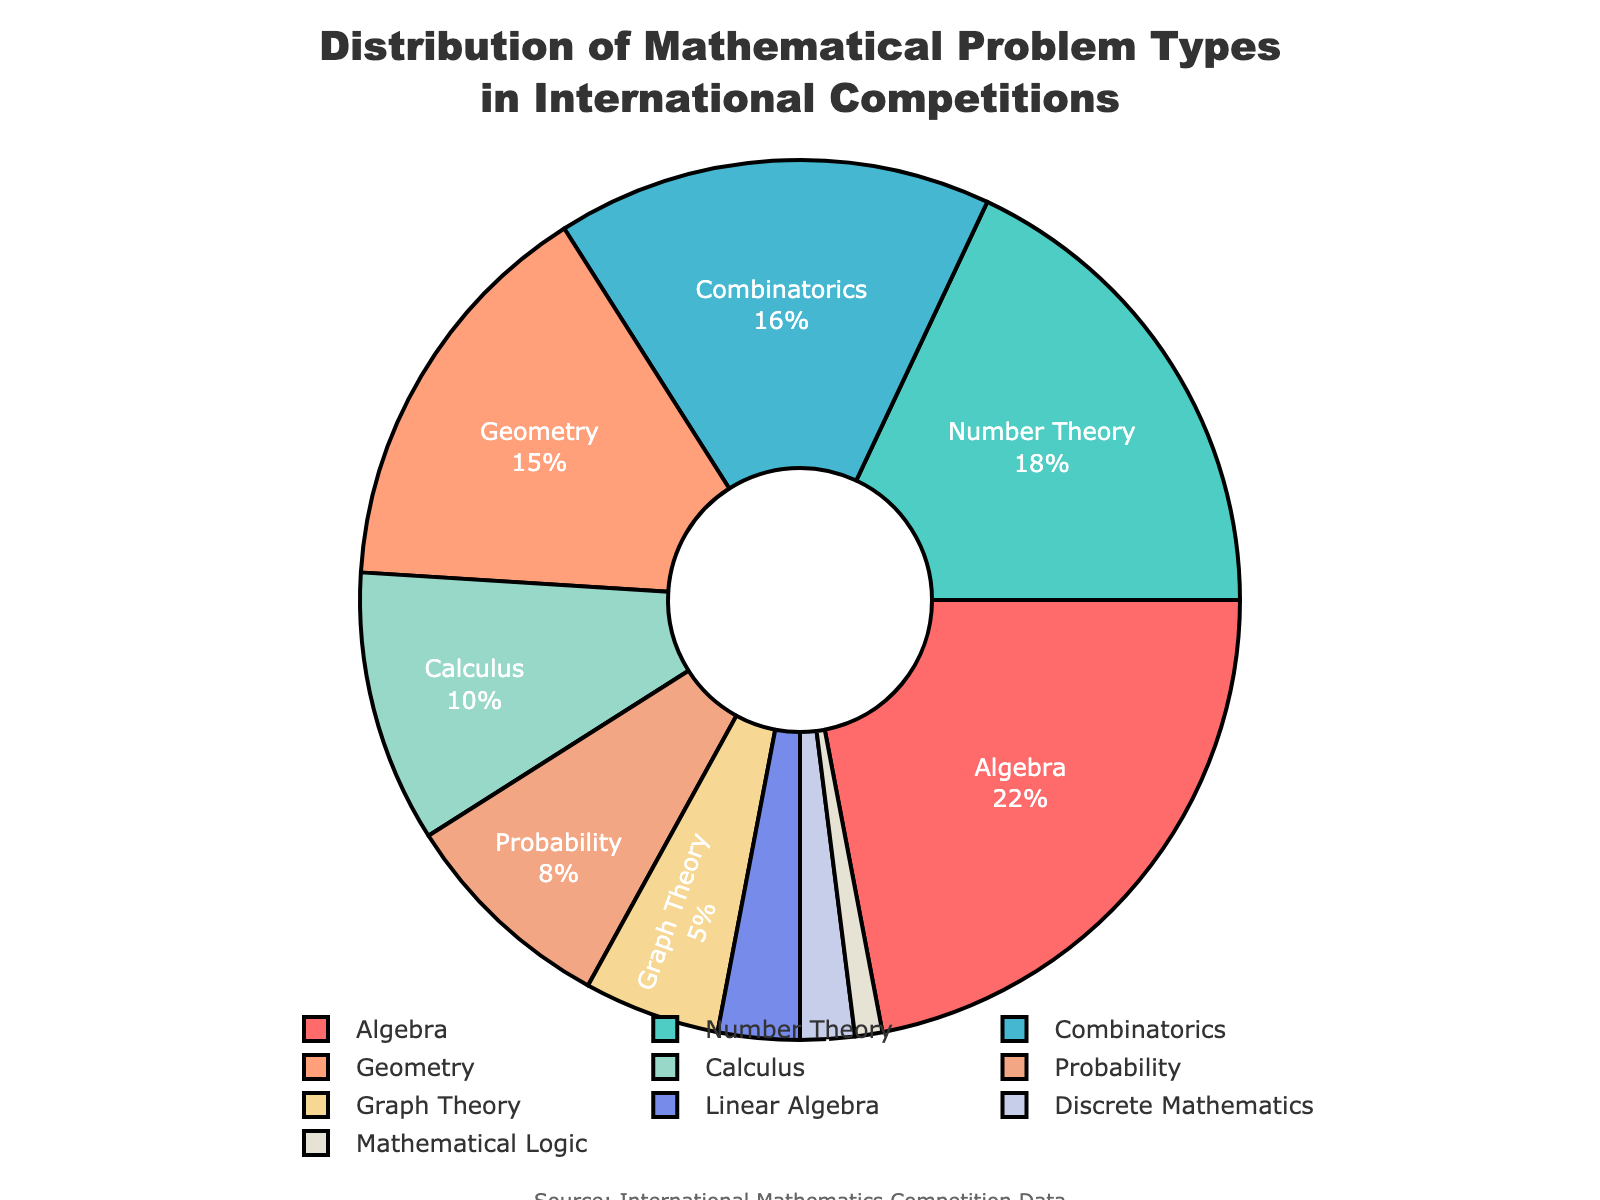Which category has the highest percentage? The category with the highest percentage can be identified by looking for the segment of the pie chart with the largest area or the largest percentage label.
Answer: Algebra What's the combined percentage of Algebra, Number Theory, and Combinatorics? Sum the percentages of these three categories: Algebra (22%), Number Theory (18%), and Combinatorics (16%). 22 + 18 + 16 = 56%.
Answer: 56% How much larger is the percentage of Probability compared to Linear Algebra? Subtract the percentage of Linear Algebra from the percentage of Probability. Probability (8%) - Linear Algebra (3%) = 5%.
Answer: 5% Which category occupies the smallest portion of the pie chart? The smallest portion of the pie chart can be identified by looking for the segment with the smallest area or the smallest percentage label.
Answer: Mathematical Logic What is the difference in percentage between the largest and smallest categories? Subtract the percentage of the smallest category from the percentage of the largest category. Algebra (22%) - Mathematical Logic (1%) = 21%.
Answer: 21% If the percentages of Geometry and Calculus were combined, would it be greater than the percentage of Algebra? Sum the percentages of Geometry and Calculus, then compare with Algebra. Geometry (15%) + Calculus (10%) = 25%. 25% is greater than 22%.
Answer: Yes Which categories together make up exactly 33% of the chart? By observation or summing different combinations, identify two or more categories that add up to 33%. Combinatorics (16%) and Probability (8%) plus Linear Algebra (3%) and Discrete Mathematics (2%) sum to 16 + 8 + 3 + 2 = 29%. Alternatively, Algebra (22%) and Graph Theory (5%) plus Discrete Mathematics (2%) and Mathematical Logic (1%) sum to 22 + 5 + 2 + 1 = 30%. No exact combination sums to 33%, combinations must be approximated.
Answer: None Which category represented by a greenish color is greater, Calculus or Probability? Identify the greenish segments in the pie chart. Calculus (blue-green) is 10%, Probability (light teal green) is 8%. By comparison, Calculus is greater.
Answer: Calculus Are there more categories with a percentage greater than or equal to 10% or less than 10%? Count the number of categories in each range. Greater than or equal to 10%: Algebra, Number Theory, Combinatorics, Geometry, Calculus (5 categories). Less than 10%: Probability, Graph Theory, Linear Algebra, Discrete Mathematics, Mathematical Logic (5 categories). There are equal numbers.
Answer: Equal What is the ratio of the percentage of Number Theory to Discrete Mathematics? Divide the percentage of Number Theory by the percentage of Discrete Mathematics. Number Theory (18%) / Discrete Mathematics (2%) = 9.
Answer: 9 